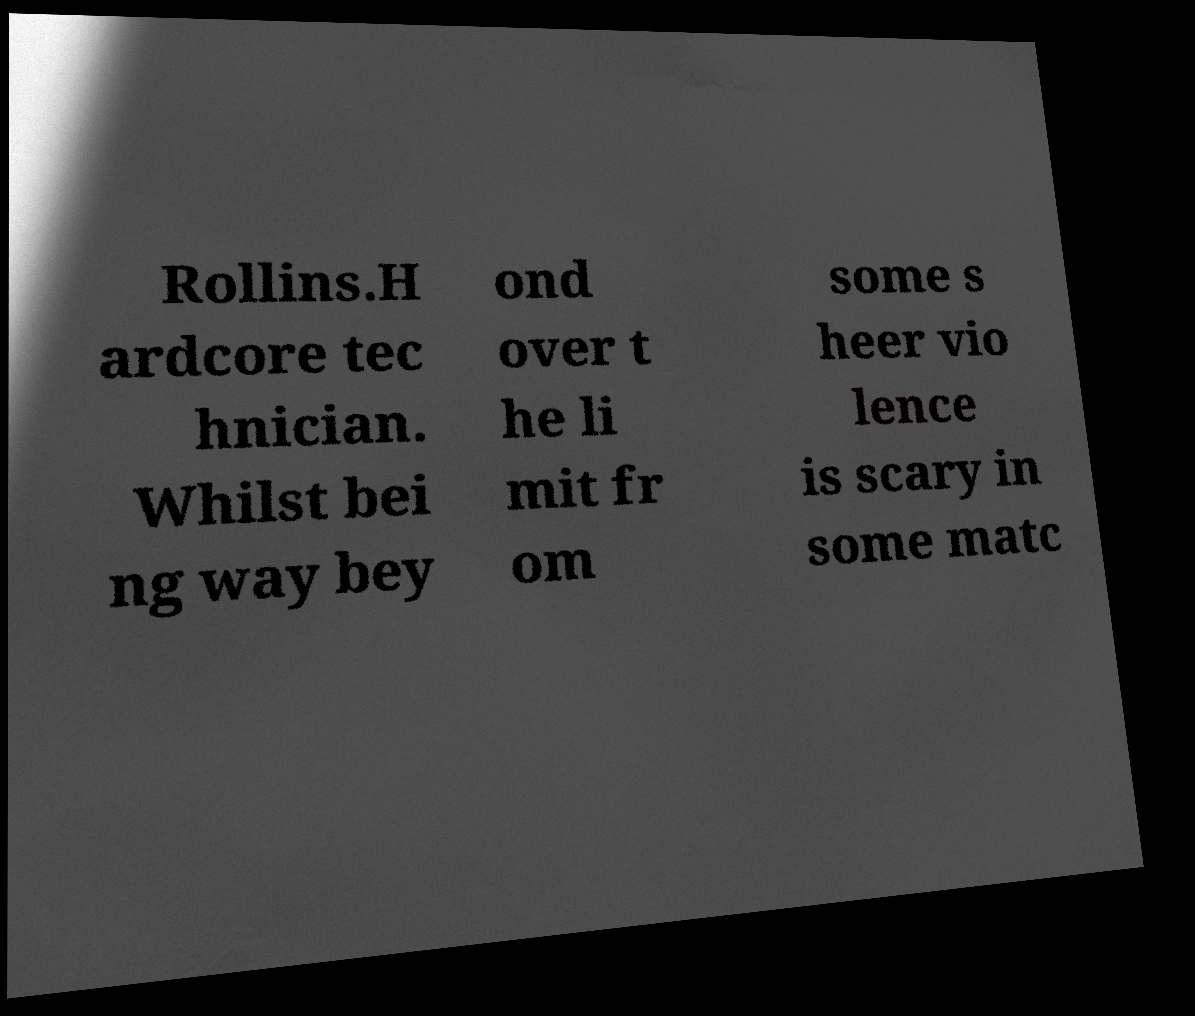For documentation purposes, I need the text within this image transcribed. Could you provide that? Rollins.H ardcore tec hnician. Whilst bei ng way bey ond over t he li mit fr om some s heer vio lence is scary in some matc 